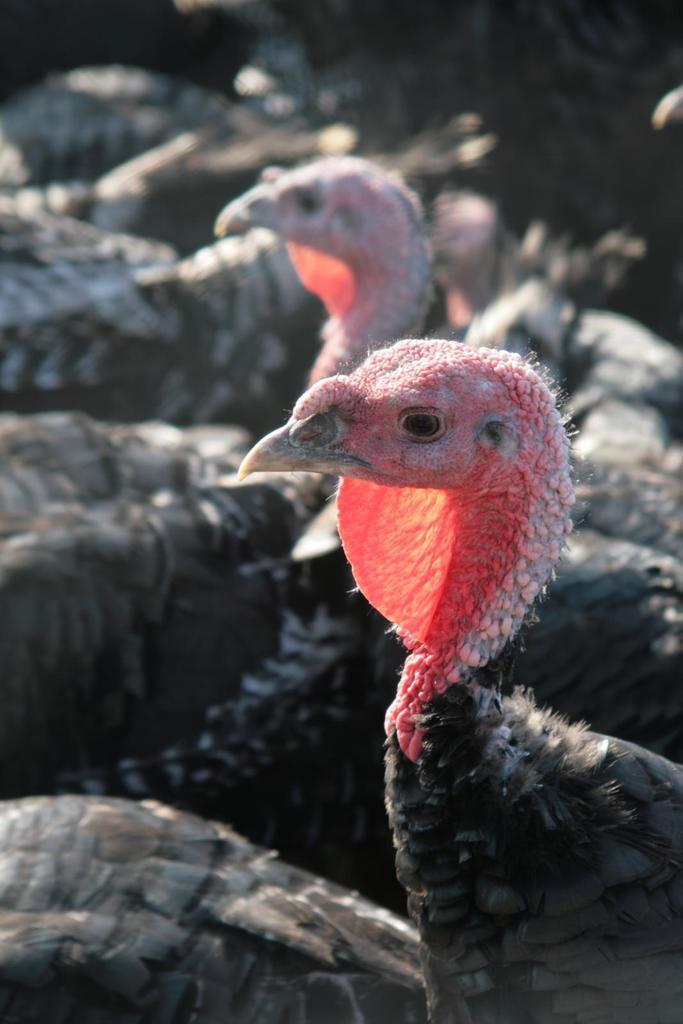Describe this image in one or two sentences. In this picture we can see a group of birds and in the background it is dark. 